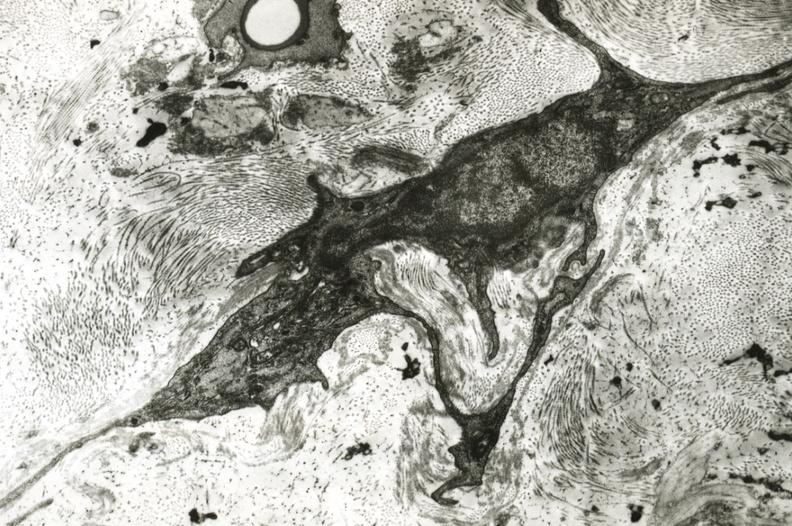what is present?
Answer the question using a single word or phrase. Cardiovascular 